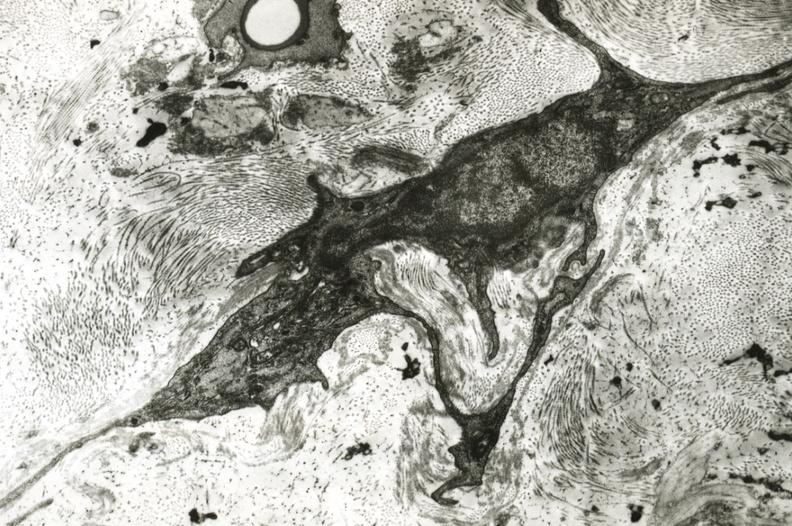what is present?
Answer the question using a single word or phrase. Cardiovascular 